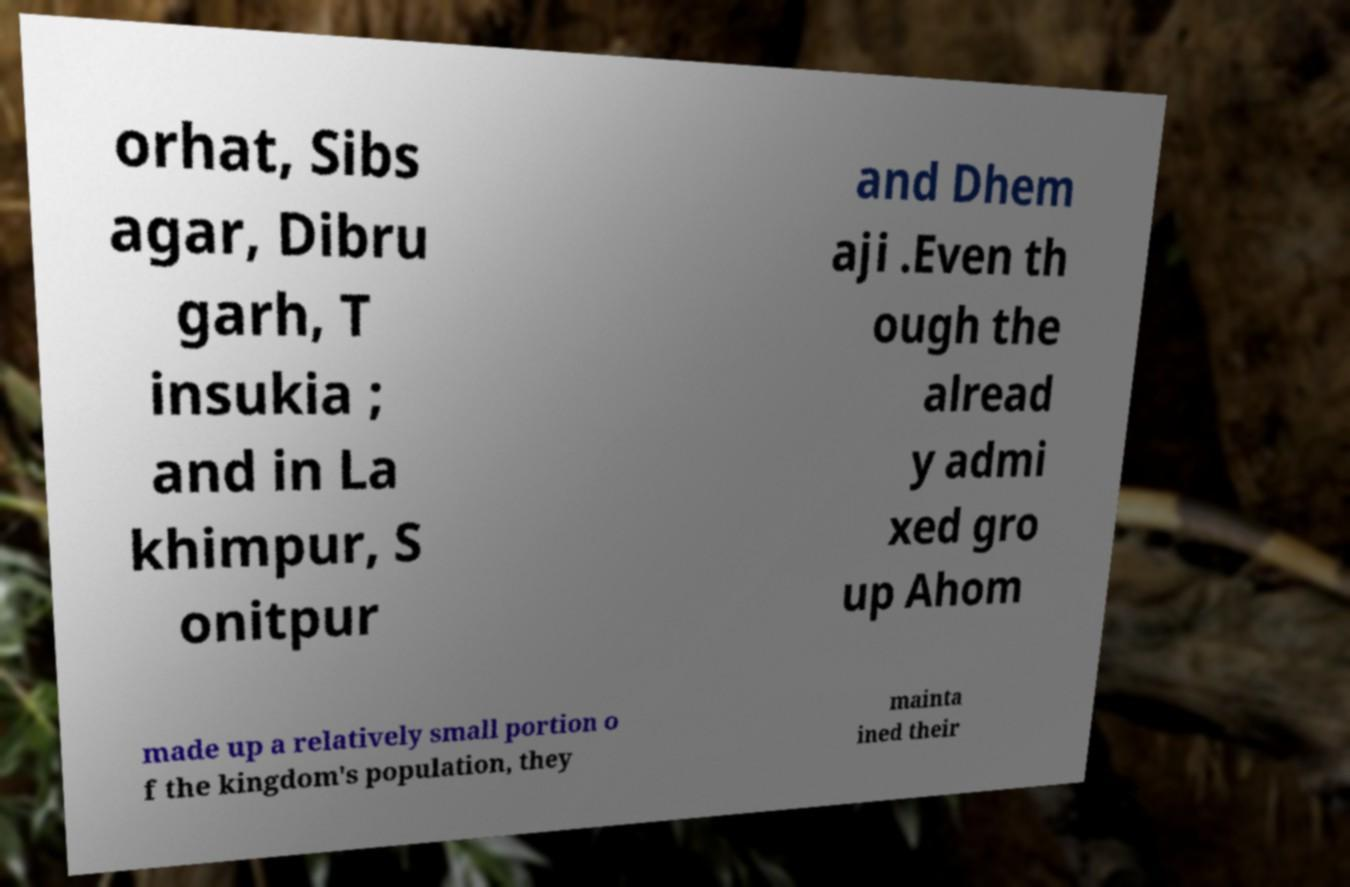Please read and relay the text visible in this image. What does it say? orhat, Sibs agar, Dibru garh, T insukia ; and in La khimpur, S onitpur and Dhem aji .Even th ough the alread y admi xed gro up Ahom made up a relatively small portion o f the kingdom's population, they mainta ined their 